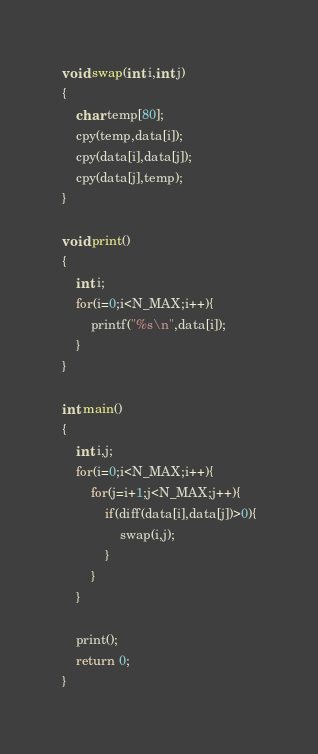<code> <loc_0><loc_0><loc_500><loc_500><_C++_>void swap(int i,int j)
{
	char temp[80];
	cpy(temp,data[i]);
	cpy(data[i],data[j]);
	cpy(data[j],temp);
}

void print()
{
	int i;
	for(i=0;i<N_MAX;i++){
		printf("%s\n",data[i]);
	}
}

int main()
{
	int i,j;
	for(i=0;i<N_MAX;i++){
		for(j=i+1;j<N_MAX;j++){
			if(diff(data[i],data[j])>0){
				swap(i,j);
			}
		}
	}
	
	print();
	return 0;
}</code> 